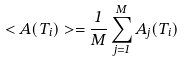Convert formula to latex. <formula><loc_0><loc_0><loc_500><loc_500>< A ( T _ { i } ) > = \frac { 1 } { M } \sum _ { j = 1 } ^ { M } A _ { j } ( T _ { i } )</formula> 